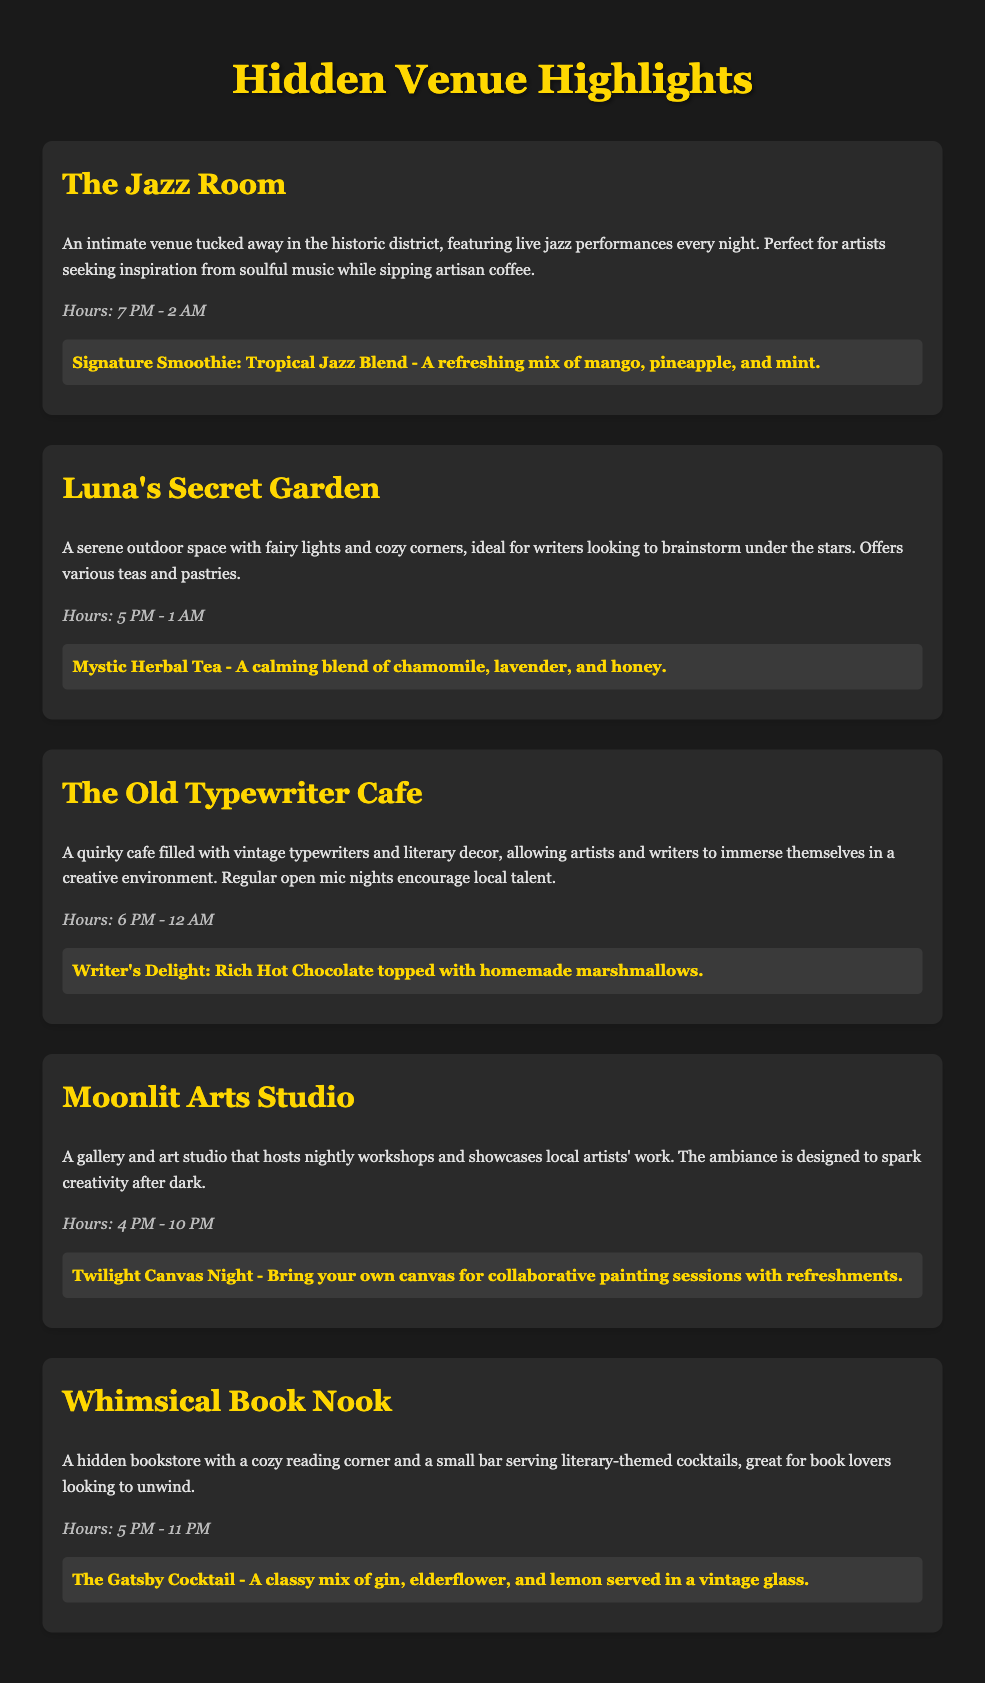What is the name of the venue that features live jazz performances? The name of the venue featuring live jazz performances is mentioned as "The Jazz Room."
Answer: The Jazz Room What are the hours of operation for Luna's Secret Garden? The hours of Luna's Secret Garden are stated in the document as "5 PM - 1 AM."
Answer: 5 PM - 1 AM What is the signature offering at The Old Typewriter Cafe? The document lists the signature offering at The Old Typewriter Cafe as "Writer's Delight: Rich Hot Chocolate topped with homemade marshmallows."
Answer: Writer's Delight: Rich Hot Chocolate topped with homemade marshmallows Which venue allows patrons to bring their own canvas? The venue that allows bringing your own canvas is "Moonlit Arts Studio."
Answer: Moonlit Arts Studio How late is Whimsical Book Nook open? The closing time for Whimsical Book Nook is mentioned as "11 PM."
Answer: 11 PM What type of environment does The Old Typewriter Cafe provide? The Old Typewriter Cafe is described as having a "quirky cafe filled with vintage typewriters and literary decor."
Answer: Quirky cafe filled with vintage typewriters and literary decor What signature drink does Luna's Secret Garden offer? The document notes the signature drink at Luna's Secret Garden as "Mystic Herbal Tea."
Answer: Mystic Herbal Tea What kind of events does Moonlit Arts Studio host? The document states that Moonlit Arts Studio hosts "nightly workshops and showcases local artists' work."
Answer: Nightly workshops and showcases local artists' work 